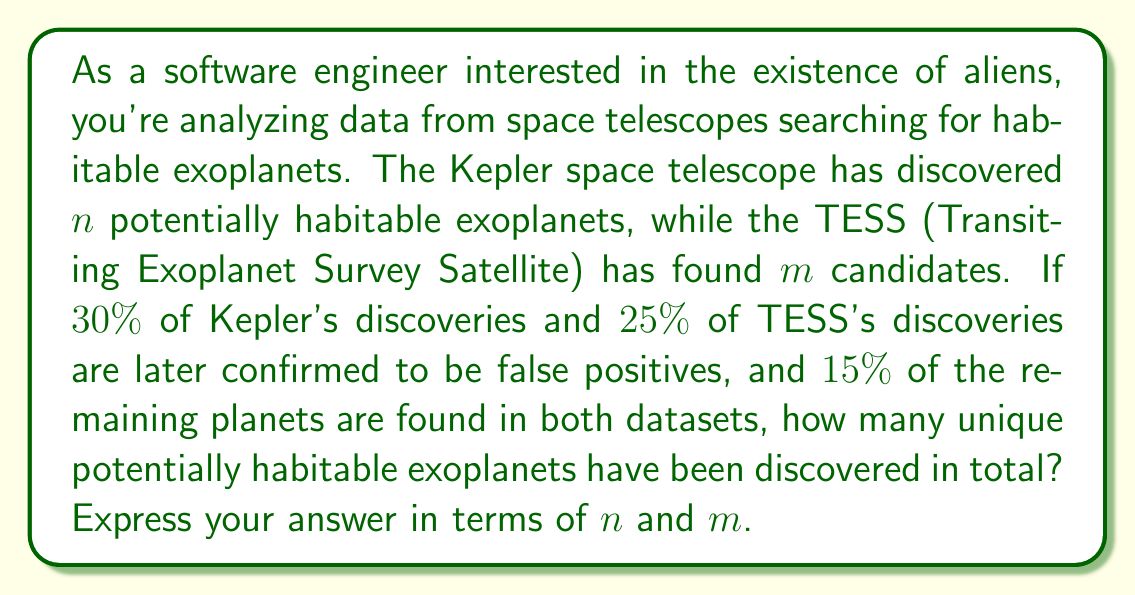Can you answer this question? Let's approach this step-by-step:

1) First, calculate the number of valid exoplanets from each telescope:
   Kepler: $0.7n$ (70% of $n$)
   TESS: $0.75m$ (75% of $m$)

2) The total number of exoplanets before accounting for overlap:
   $$ 0.7n + 0.75m $$

3) Now, we need to subtract the overlap. The overlap is 15% of this total:
   $$ 0.15(0.7n + 0.75m) $$

4) To get the final count, we subtract the overlap from the total:
   $$ (0.7n + 0.75m) - 0.15(0.7n + 0.75m) $$

5) Simplify:
   $$ 0.85(0.7n + 0.75m) $$

6) Distribute:
   $$ 0.595n + 0.6375m $$

Therefore, the number of unique potentially habitable exoplanets is $0.595n + 0.6375m$.
Answer: $0.595n + 0.6375m$ 